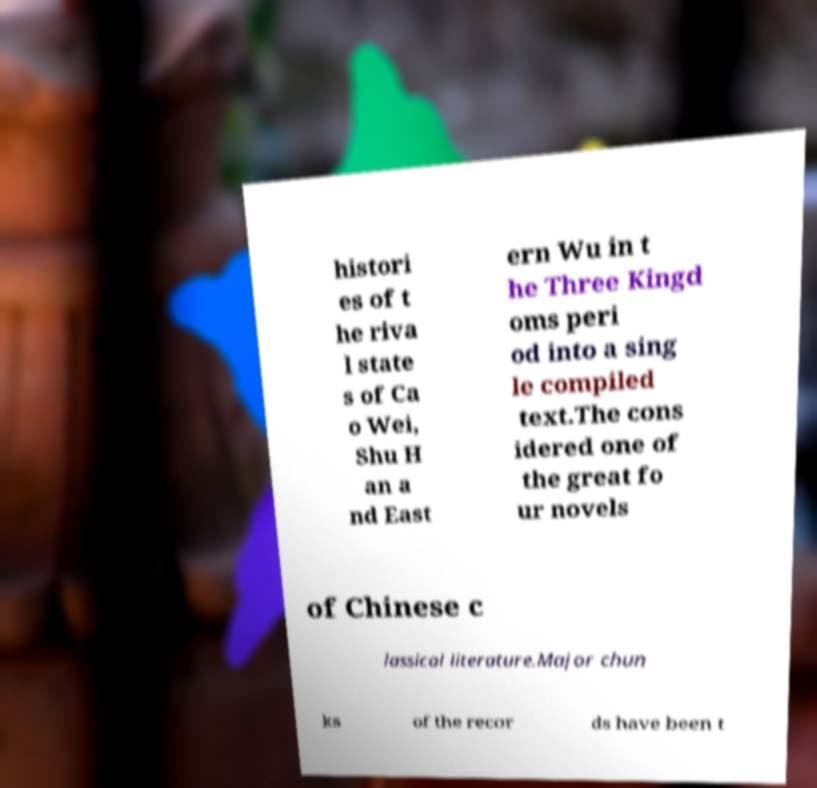For documentation purposes, I need the text within this image transcribed. Could you provide that? histori es of t he riva l state s of Ca o Wei, Shu H an a nd East ern Wu in t he Three Kingd oms peri od into a sing le compiled text.The cons idered one of the great fo ur novels of Chinese c lassical literature.Major chun ks of the recor ds have been t 